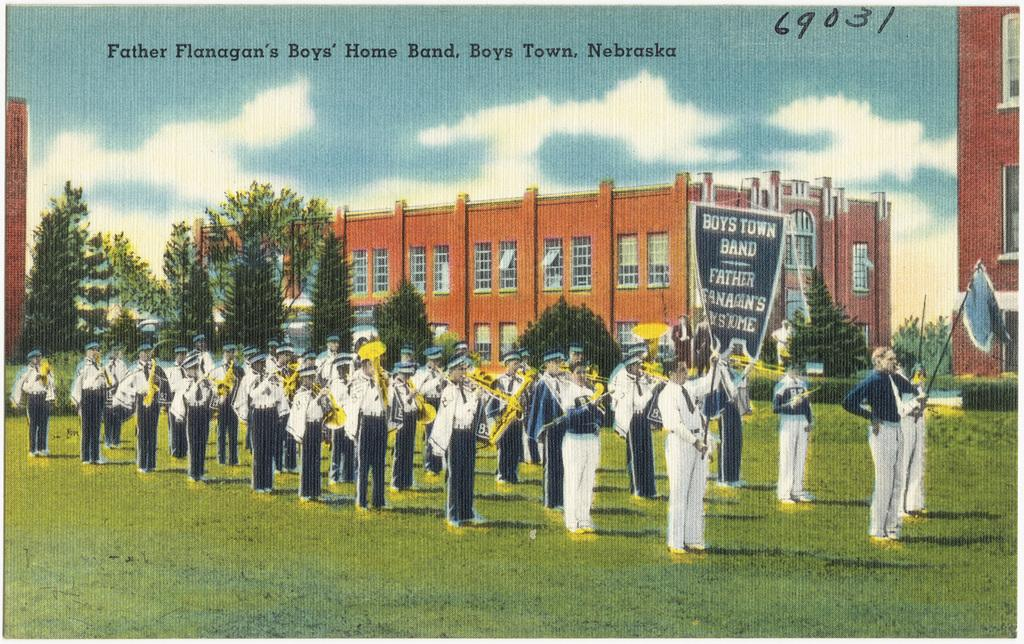<image>
Share a concise interpretation of the image provided. A marching band from Father Flanagan's Boys' home. 